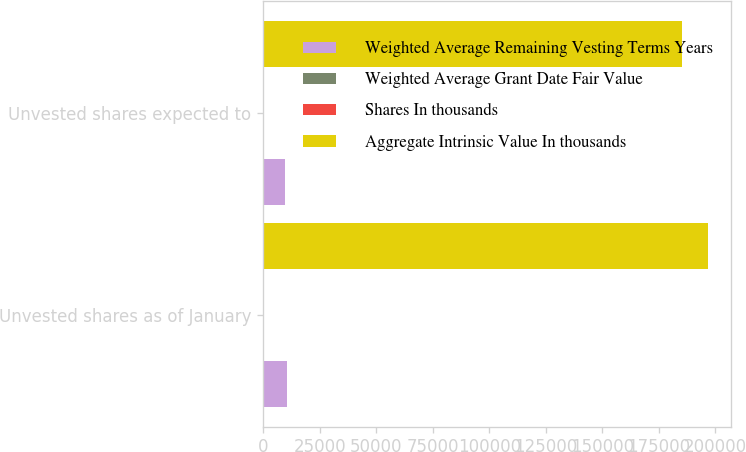<chart> <loc_0><loc_0><loc_500><loc_500><stacked_bar_chart><ecel><fcel>Unvested shares as of January<fcel>Unvested shares expected to<nl><fcel>Weighted Average Remaining Vesting Terms Years<fcel>10451<fcel>9846<nl><fcel>Weighted Average Grant Date Fair Value<fcel>15.51<fcel>15.47<nl><fcel>Shares In thousands<fcel>1.1<fcel>1.1<nl><fcel>Aggregate Intrinsic Value In thousands<fcel>196801<fcel>185398<nl></chart> 